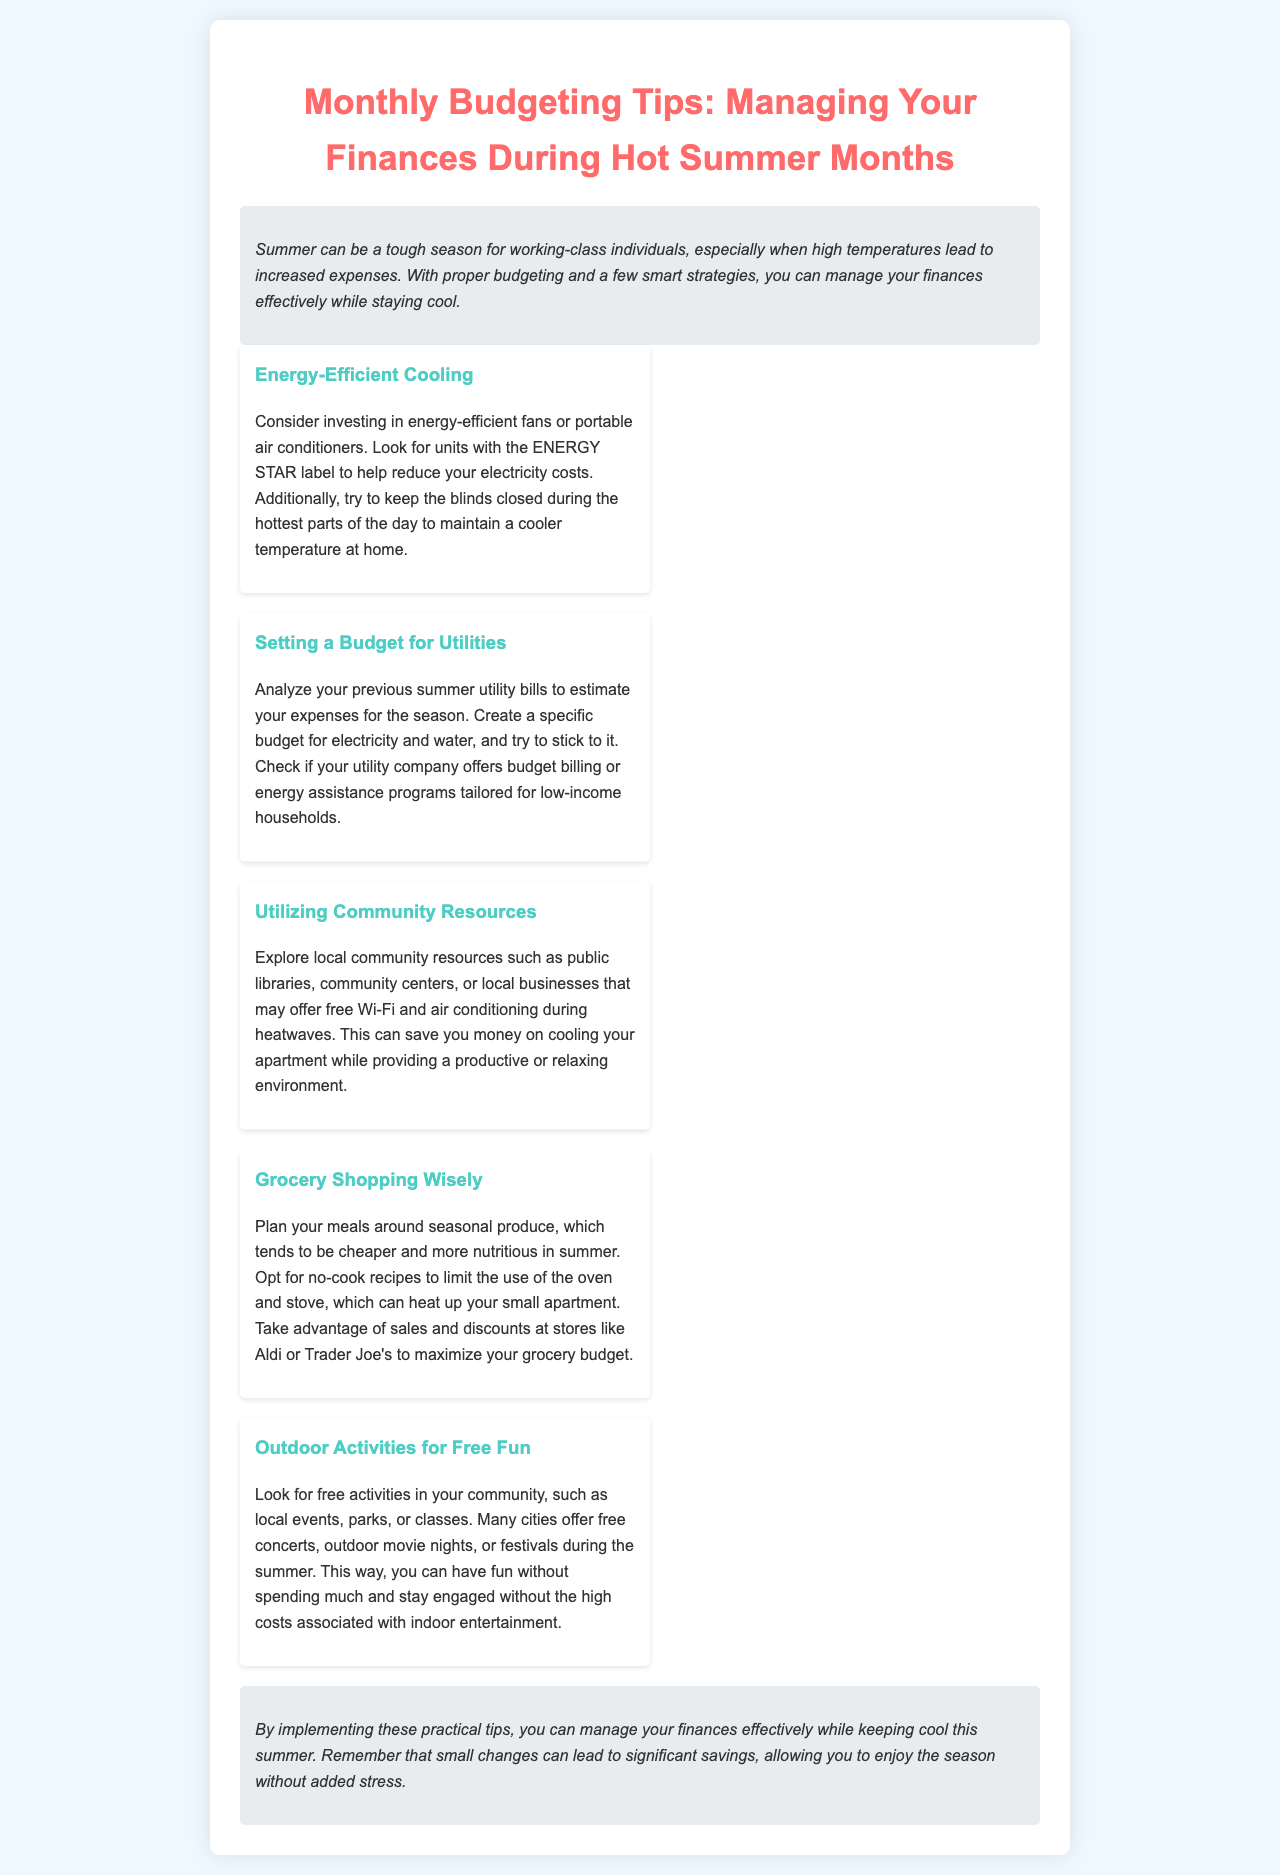what is the title of the document? The title of the document is prominently displayed at the top of the newsletter.
Answer: Monthly Budgeting Tips: Managing Your Finances During Hot Summer Months what is suggested for cooling your apartment? The document recommends investing in energy-efficient fans or portable air conditioners.
Answer: Energy-efficient fans or portable air conditioners how can you estimate your utility expenses? The document suggests analyzing previous summer utility bills to create an estimate.
Answer: Analyzing previous summer utility bills what type of recipes are recommended to limit heat? It advises opting for no-cook recipes to avoid using the oven and stove.
Answer: No-cook recipes where can you find free Wi-Fi and air conditioning? Local community resources such as public libraries and community centers may offer these services.
Answer: Public libraries and community centers what is the main focus of this newsletter? The newsletter focuses on providing budgeting tips to manage finances during hot summer months.
Answer: Budgeting tips to manage finances during hot summer months how can seasonal produce benefit your grocery shopping? Seasonal produce tends to be cheaper and more nutritious in summer.
Answer: Cheaper and more nutritious what is a recommended outdoor activity for low-cost fun? The document suggests looking for free local events or community activities during summer.
Answer: Free local events or community activities 